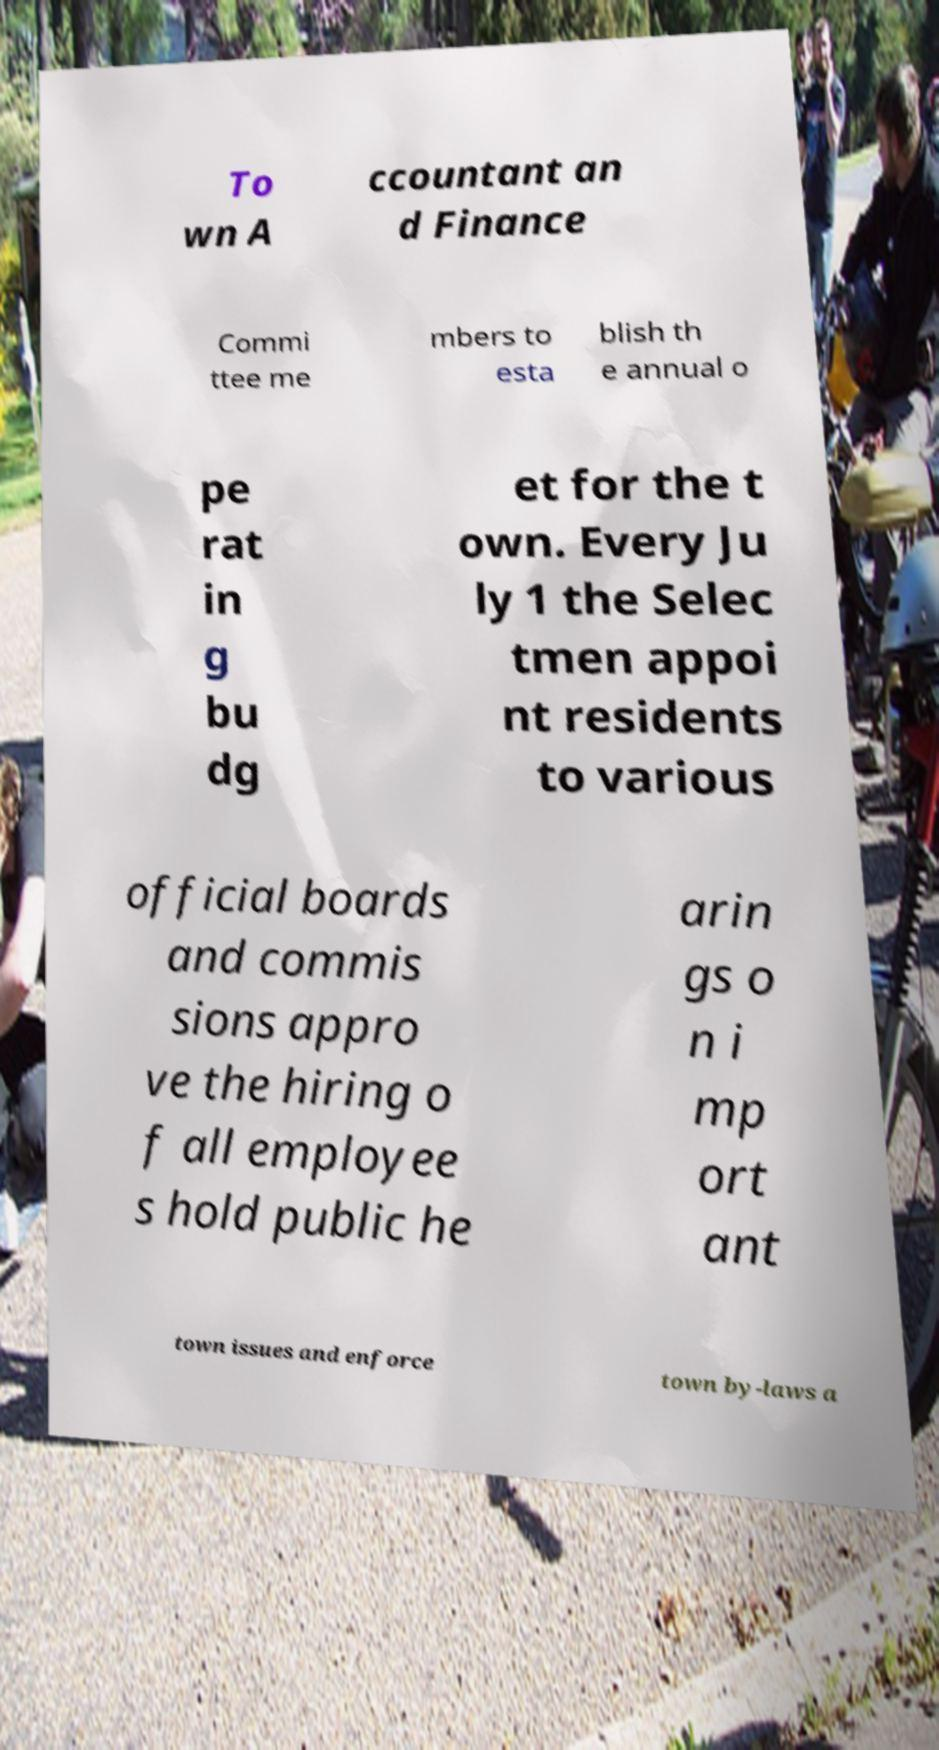I need the written content from this picture converted into text. Can you do that? To wn A ccountant an d Finance Commi ttee me mbers to esta blish th e annual o pe rat in g bu dg et for the t own. Every Ju ly 1 the Selec tmen appoi nt residents to various official boards and commis sions appro ve the hiring o f all employee s hold public he arin gs o n i mp ort ant town issues and enforce town by-laws a 